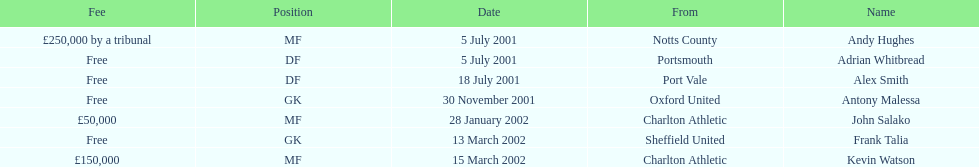Did andy hughes or john salako command the largest fee? Andy Hughes. 